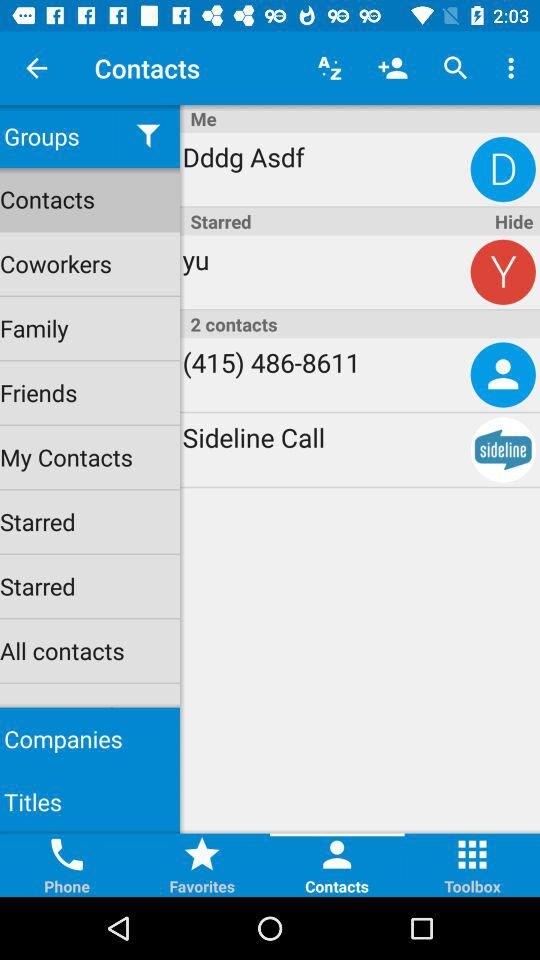How many contacts are there? There are 2 contacts. 